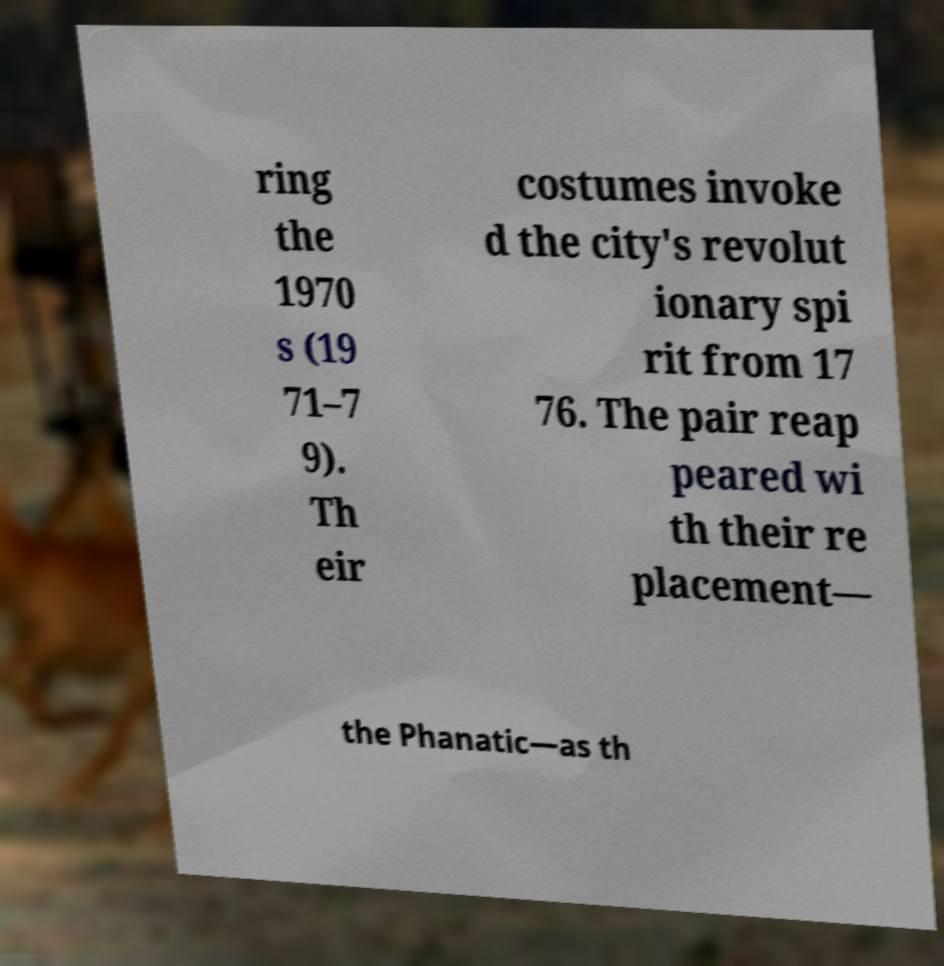Can you accurately transcribe the text from the provided image for me? ring the 1970 s (19 71–7 9). Th eir costumes invoke d the city's revolut ionary spi rit from 17 76. The pair reap peared wi th their re placement— the Phanatic—as th 